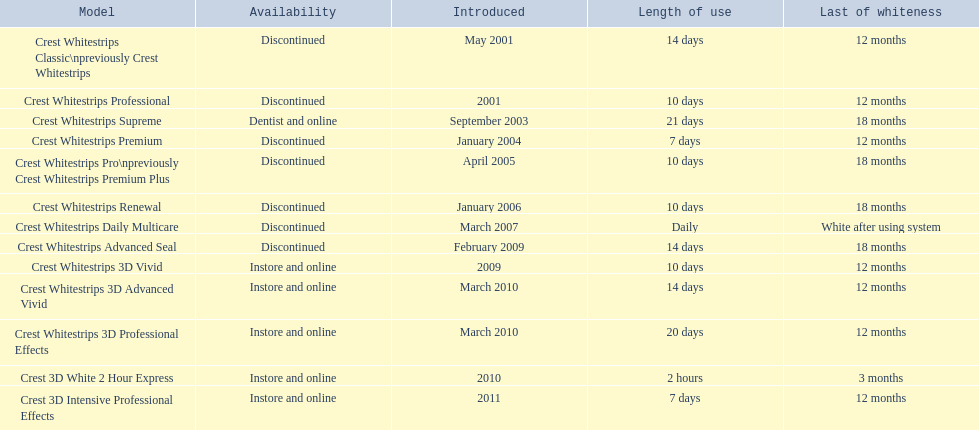Which discontinued product was introduced the same year as crest whitestrips 3d vivid? Crest Whitestrips Advanced Seal. 